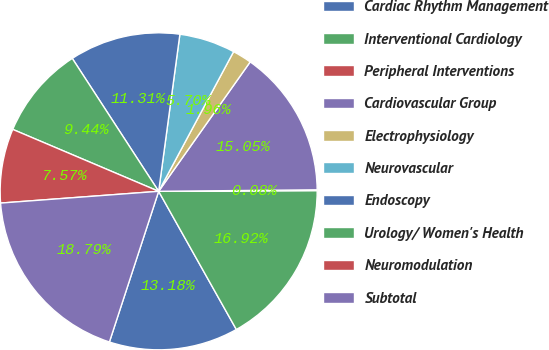Convert chart. <chart><loc_0><loc_0><loc_500><loc_500><pie_chart><fcel>Cardiac Rhythm Management<fcel>Interventional Cardiology<fcel>Peripheral Interventions<fcel>Cardiovascular Group<fcel>Electrophysiology<fcel>Neurovascular<fcel>Endoscopy<fcel>Urology/ Women's Health<fcel>Neuromodulation<fcel>Subtotal<nl><fcel>13.18%<fcel>16.92%<fcel>0.08%<fcel>15.05%<fcel>1.96%<fcel>5.7%<fcel>11.31%<fcel>9.44%<fcel>7.57%<fcel>18.79%<nl></chart> 